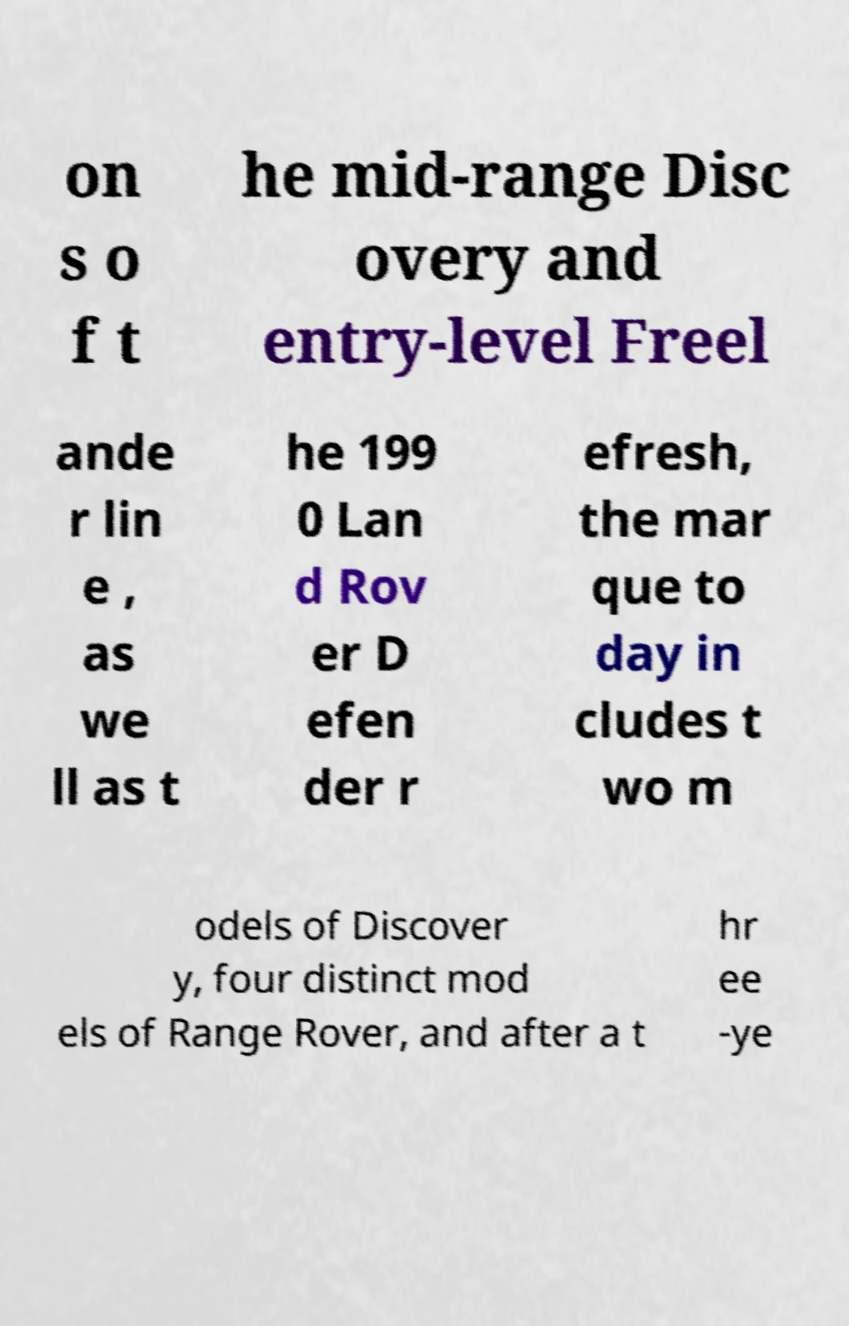Please read and relay the text visible in this image. What does it say? on s o f t he mid-range Disc overy and entry-level Freel ande r lin e , as we ll as t he 199 0 Lan d Rov er D efen der r efresh, the mar que to day in cludes t wo m odels of Discover y, four distinct mod els of Range Rover, and after a t hr ee -ye 